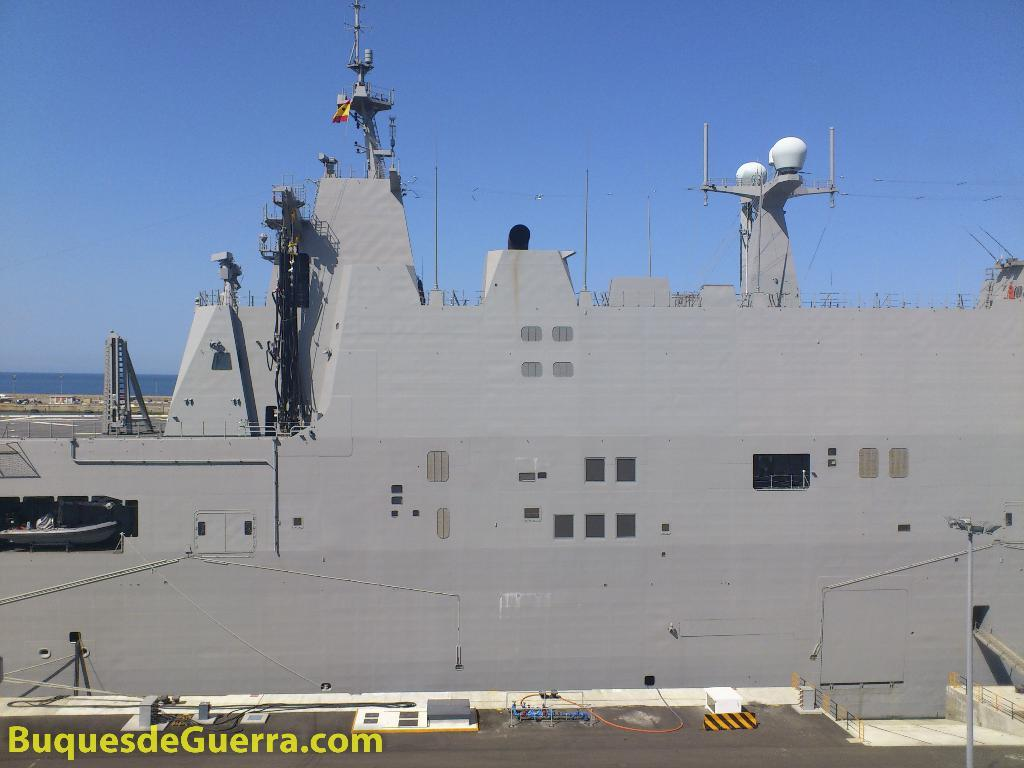What type of structures can be seen in the image? There are buildings in the image. What is visible at the top of the image? The sky is visible at the top of the image. What type of sweater is being worn by the ship in the image? There is no ship present in the image, and therefore no sweater can be associated with it. 